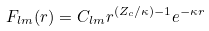<formula> <loc_0><loc_0><loc_500><loc_500>F _ { l m } ( r ) = C _ { l m } r ^ { ( Z _ { c } / \kappa ) - 1 } e ^ { - \kappa r }</formula> 